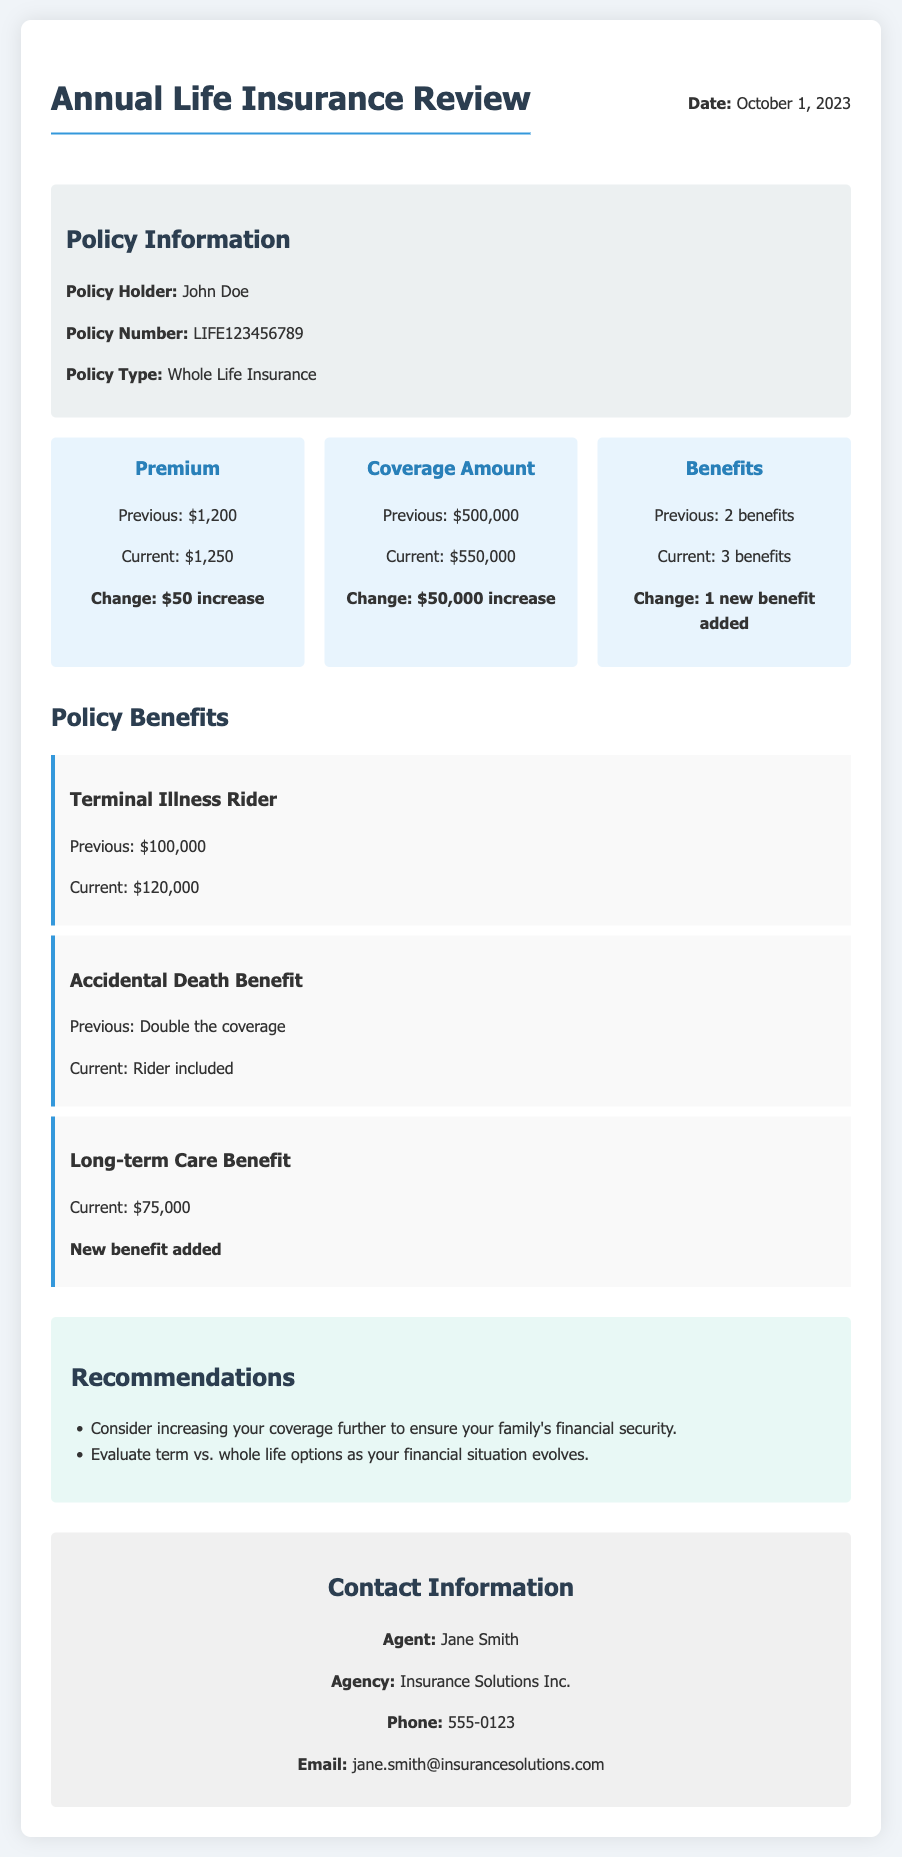What is the policy holder's name? The policy holder's name is listed in the policy information section as John Doe.
Answer: John Doe What is the previous premium amount? The previous premium amount is detailed in the summary and is indicated as $1,200.
Answer: $1,200 What is the current coverage amount? The current coverage amount can be found in the summary, specifically noted as $550,000.
Answer: $550,000 How many benefits are currently included in the policy? The current number of benefits is mentioned in the summary, indicating that there are 3 benefits.
Answer: 3 benefits What is the change in the Terminal Illness Rider benefit? The change in the Terminal Illness Rider benefit is specified as an increase from $100,000 to $120,000.
Answer: $20,000 increase What recommendation is made regarding coverage? One of the recommendations suggests considering increasing your coverage further to ensure your family's financial security.
Answer: Increase coverage What type of insurance is this policy? The type of insurance policy is specified in the policy information section as Whole Life Insurance.
Answer: Whole Life Insurance Who is the insurance agent? The insurance agent's name is listed in the contact information as Jane Smith.
Answer: Jane Smith What date is the annual review scheduled? The date of the annual review is mentioned at the top of the document as October 1, 2023.
Answer: October 1, 2023 